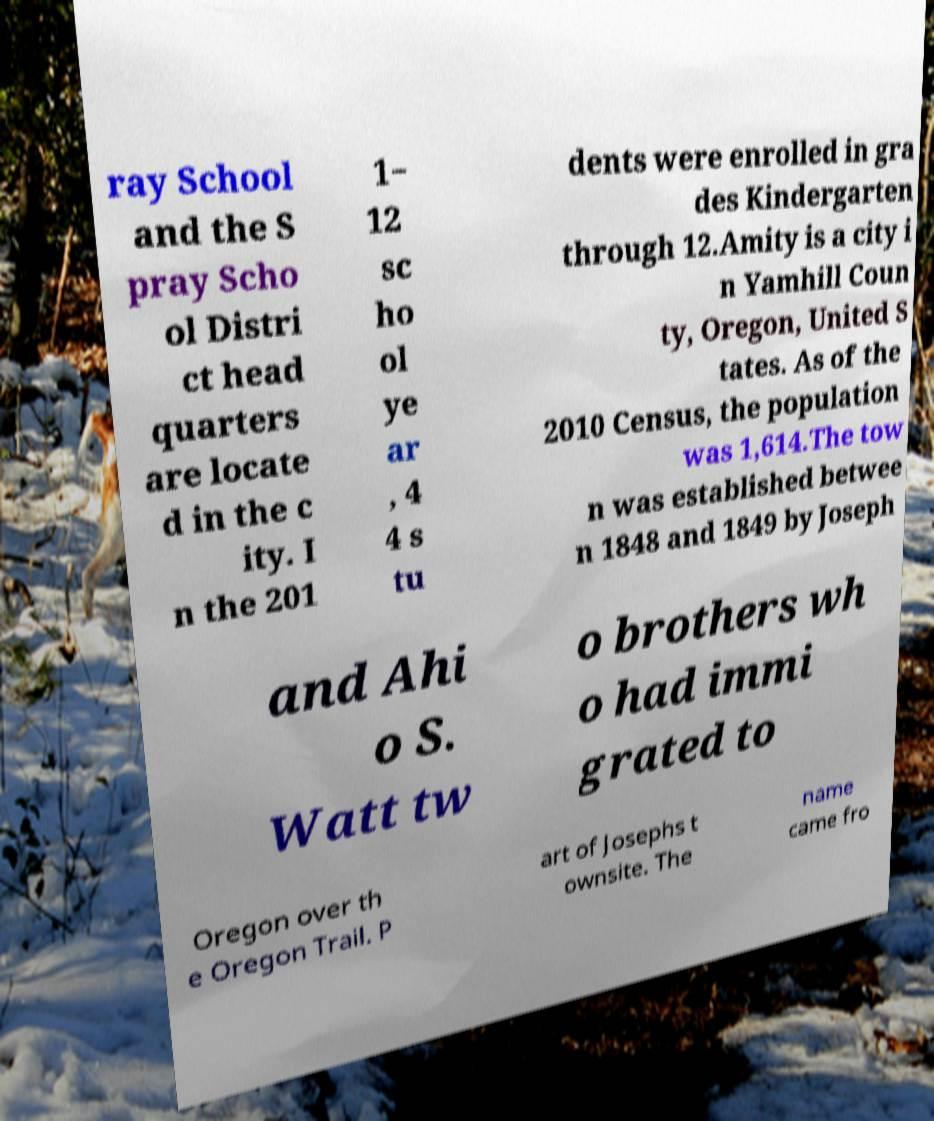Can you read and provide the text displayed in the image?This photo seems to have some interesting text. Can you extract and type it out for me? ray School and the S pray Scho ol Distri ct head quarters are locate d in the c ity. I n the 201 1− 12 sc ho ol ye ar , 4 4 s tu dents were enrolled in gra des Kindergarten through 12.Amity is a city i n Yamhill Coun ty, Oregon, United S tates. As of the 2010 Census, the population was 1,614.The tow n was established betwee n 1848 and 1849 by Joseph and Ahi o S. Watt tw o brothers wh o had immi grated to Oregon over th e Oregon Trail. P art of Josephs t ownsite. The name came fro 